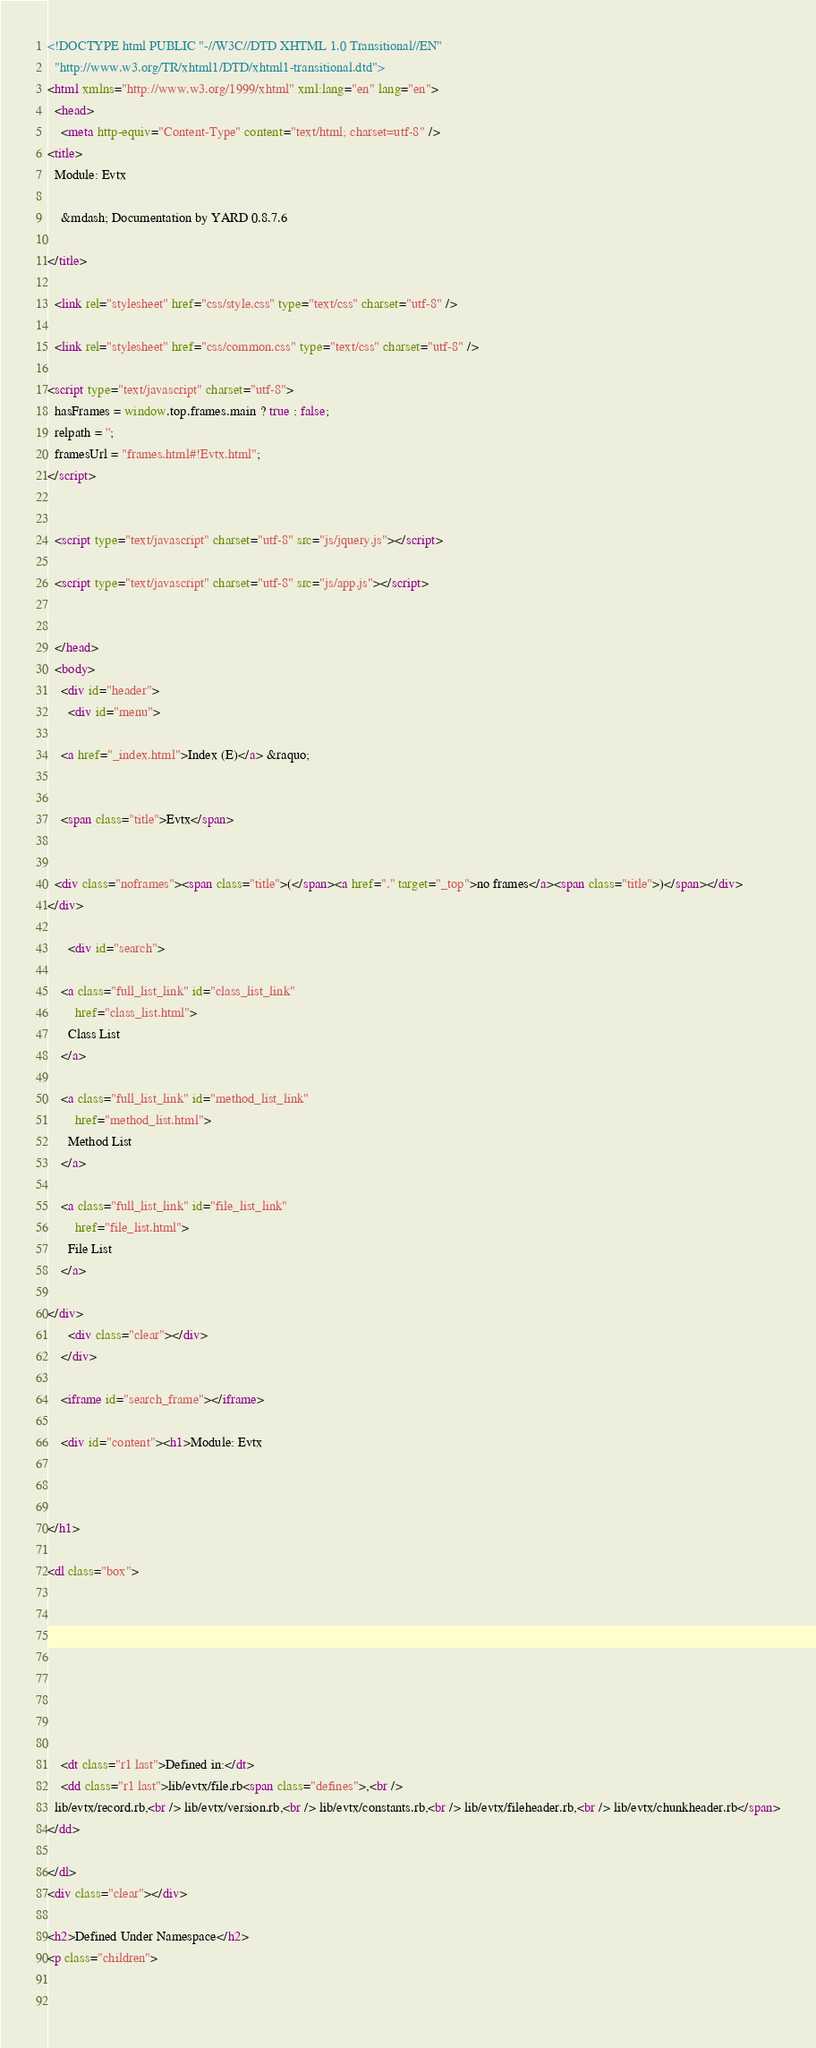<code> <loc_0><loc_0><loc_500><loc_500><_HTML_><!DOCTYPE html PUBLIC "-//W3C//DTD XHTML 1.0 Transitional//EN"
  "http://www.w3.org/TR/xhtml1/DTD/xhtml1-transitional.dtd">
<html xmlns="http://www.w3.org/1999/xhtml" xml:lang="en" lang="en">
  <head>
    <meta http-equiv="Content-Type" content="text/html; charset=utf-8" />
<title>
  Module: Evtx
  
    &mdash; Documentation by YARD 0.8.7.6
  
</title>

  <link rel="stylesheet" href="css/style.css" type="text/css" charset="utf-8" />

  <link rel="stylesheet" href="css/common.css" type="text/css" charset="utf-8" />

<script type="text/javascript" charset="utf-8">
  hasFrames = window.top.frames.main ? true : false;
  relpath = '';
  framesUrl = "frames.html#!Evtx.html";
</script>


  <script type="text/javascript" charset="utf-8" src="js/jquery.js"></script>

  <script type="text/javascript" charset="utf-8" src="js/app.js"></script>


  </head>
  <body>
    <div id="header">
      <div id="menu">
  
    <a href="_index.html">Index (E)</a> &raquo;
    
    
    <span class="title">Evtx</span>
  

  <div class="noframes"><span class="title">(</span><a href="." target="_top">no frames</a><span class="title">)</span></div>
</div>

      <div id="search">
  
    <a class="full_list_link" id="class_list_link"
        href="class_list.html">
      Class List
    </a>
  
    <a class="full_list_link" id="method_list_link"
        href="method_list.html">
      Method List
    </a>
  
    <a class="full_list_link" id="file_list_link"
        href="file_list.html">
      File List
    </a>
  
</div>
      <div class="clear"></div>
    </div>

    <iframe id="search_frame"></iframe>

    <div id="content"><h1>Module: Evtx
  
  
  
</h1>

<dl class="box">
  
  
    
  
    
  
  
  
    <dt class="r1 last">Defined in:</dt>
    <dd class="r1 last">lib/evtx/file.rb<span class="defines">,<br />
  lib/evtx/record.rb,<br /> lib/evtx/version.rb,<br /> lib/evtx/constants.rb,<br /> lib/evtx/fileheader.rb,<br /> lib/evtx/chunkheader.rb</span>
</dd>
  
</dl>
<div class="clear"></div>

<h2>Defined Under Namespace</h2>
<p class="children">
  
    </code> 